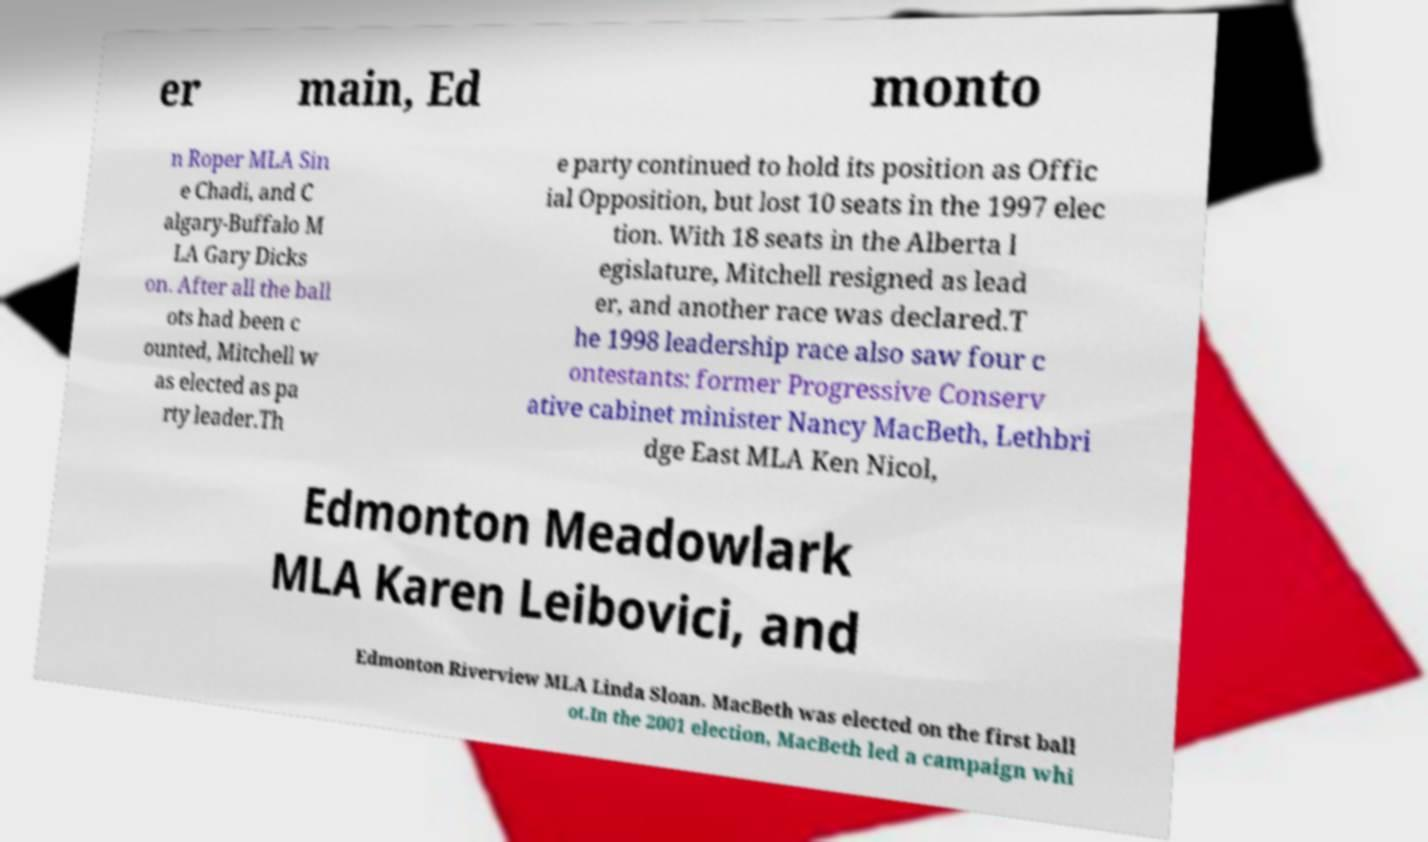Please read and relay the text visible in this image. What does it say? er main, Ed monto n Roper MLA Sin e Chadi, and C algary-Buffalo M LA Gary Dicks on. After all the ball ots had been c ounted, Mitchell w as elected as pa rty leader.Th e party continued to hold its position as Offic ial Opposition, but lost 10 seats in the 1997 elec tion. With 18 seats in the Alberta l egislature, Mitchell resigned as lead er, and another race was declared.T he 1998 leadership race also saw four c ontestants: former Progressive Conserv ative cabinet minister Nancy MacBeth, Lethbri dge East MLA Ken Nicol, Edmonton Meadowlark MLA Karen Leibovici, and Edmonton Riverview MLA Linda Sloan. MacBeth was elected on the first ball ot.In the 2001 election, MacBeth led a campaign whi 